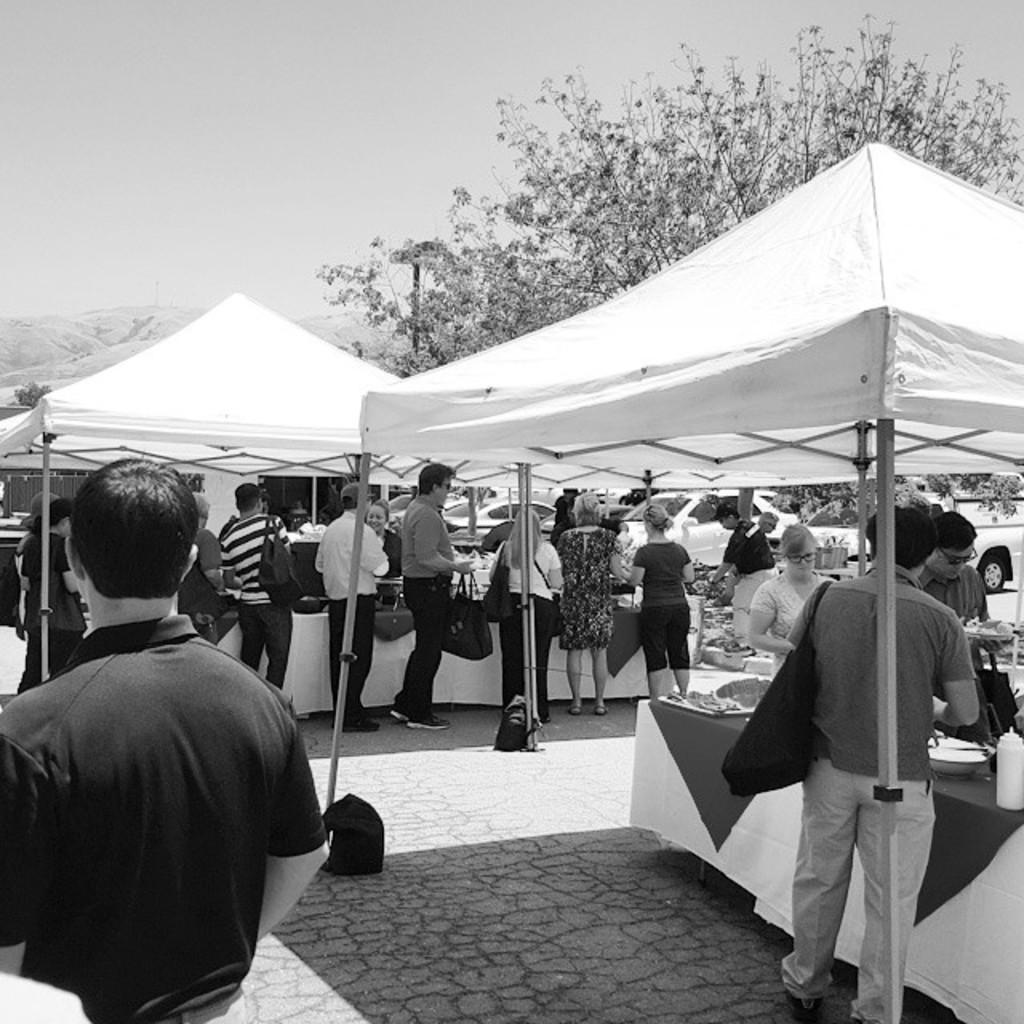In one or two sentences, can you explain what this image depicts? In this there are stalls on the right and left side of the image and there are people in the center of the image, there are cars on the right side of the image, there is a tree on the right side of the image. 